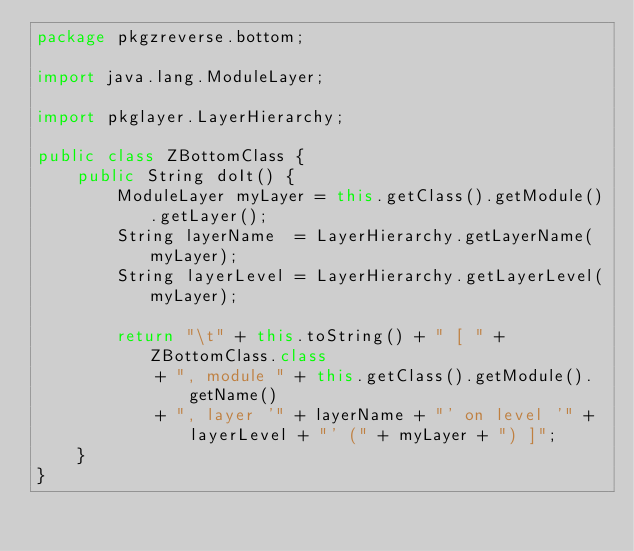Convert code to text. <code><loc_0><loc_0><loc_500><loc_500><_Java_>package pkgzreverse.bottom;

import java.lang.ModuleLayer;

import pkglayer.LayerHierarchy;

public class ZBottomClass {
    public String doIt() {
        ModuleLayer myLayer = this.getClass().getModule().getLayer();
        String layerName  = LayerHierarchy.getLayerName(myLayer);
        String layerLevel = LayerHierarchy.getLayerLevel(myLayer);

        return "\t" + this.toString() + " [ " + ZBottomClass.class
            + ", module " + this.getClass().getModule().getName() 
            + ", layer '" + layerName + "' on level '" + layerLevel + "' (" + myLayer + ") ]";
    }
}
</code> 